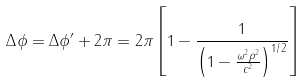Convert formula to latex. <formula><loc_0><loc_0><loc_500><loc_500>\Delta \phi = \Delta \phi ^ { \prime } + 2 \pi = 2 \pi \left [ 1 - \frac { 1 } { \left ( 1 - \frac { \omega ^ { 2 } \rho ^ { 2 } } { c ^ { 2 } } \right ) ^ { 1 / 2 } } \right ]</formula> 